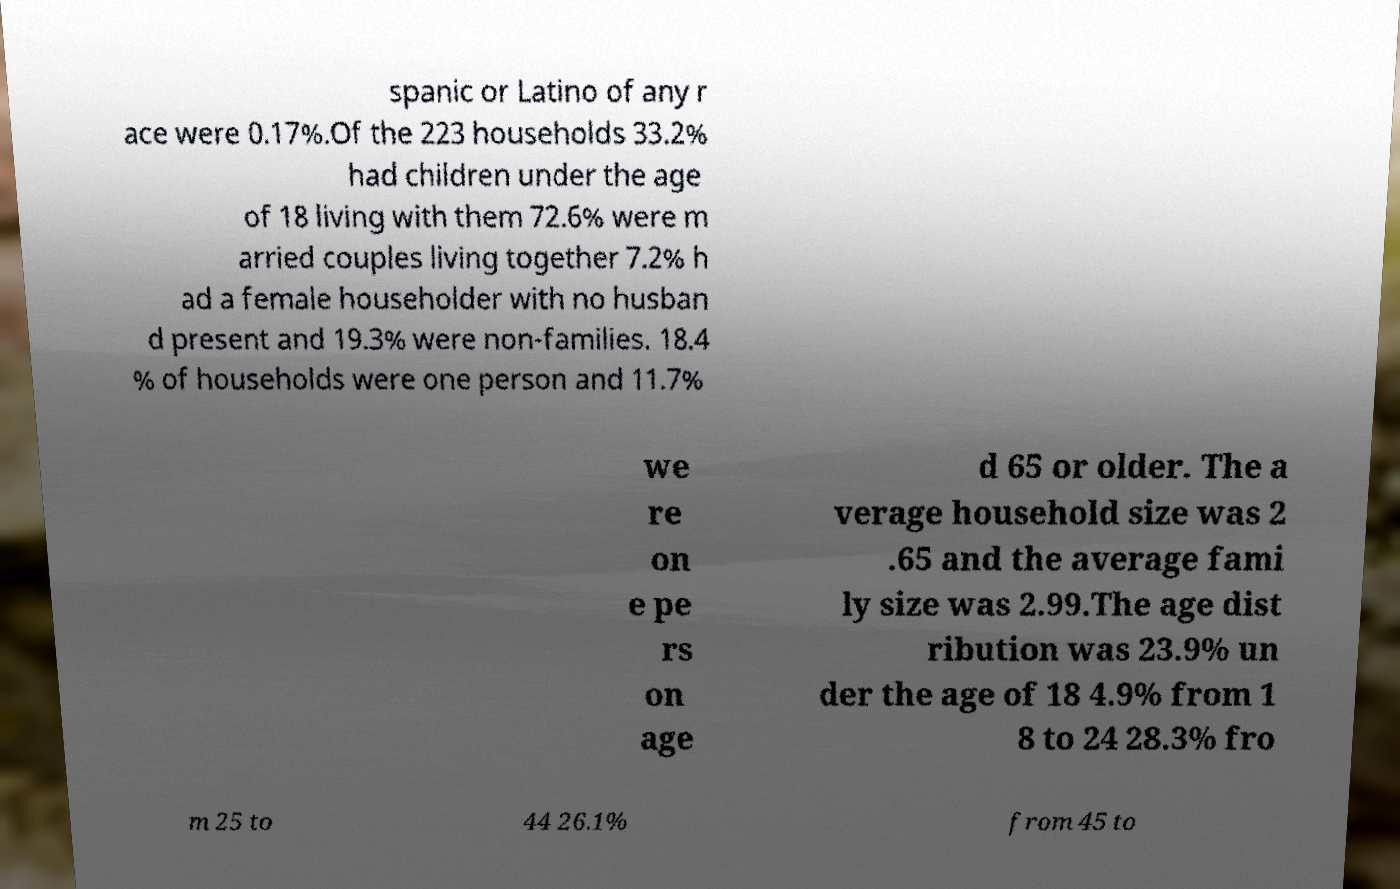What messages or text are displayed in this image? I need them in a readable, typed format. spanic or Latino of any r ace were 0.17%.Of the 223 households 33.2% had children under the age of 18 living with them 72.6% were m arried couples living together 7.2% h ad a female householder with no husban d present and 19.3% were non-families. 18.4 % of households were one person and 11.7% we re on e pe rs on age d 65 or older. The a verage household size was 2 .65 and the average fami ly size was 2.99.The age dist ribution was 23.9% un der the age of 18 4.9% from 1 8 to 24 28.3% fro m 25 to 44 26.1% from 45 to 